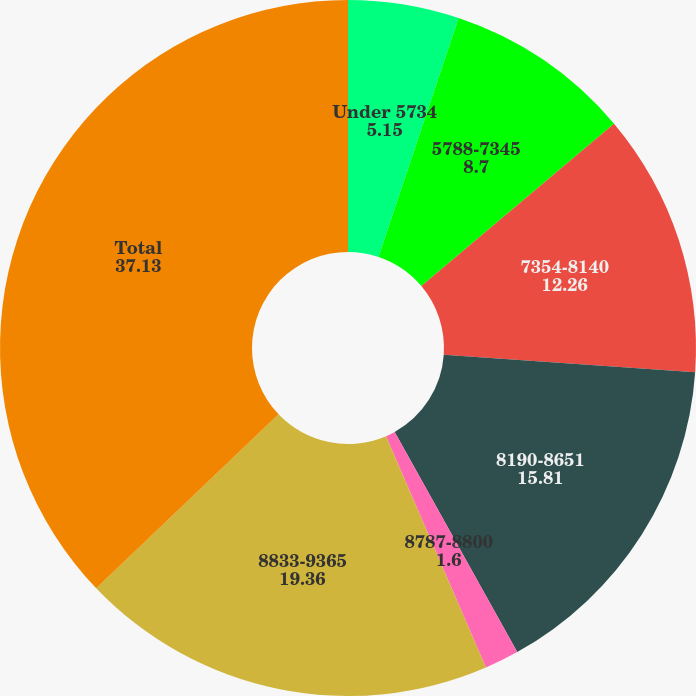Convert chart. <chart><loc_0><loc_0><loc_500><loc_500><pie_chart><fcel>Under 5734<fcel>5788-7345<fcel>7354-8140<fcel>8190-8651<fcel>8787-8800<fcel>8833-9365<fcel>Total<nl><fcel>5.15%<fcel>8.7%<fcel>12.26%<fcel>15.81%<fcel>1.6%<fcel>19.36%<fcel>37.13%<nl></chart> 